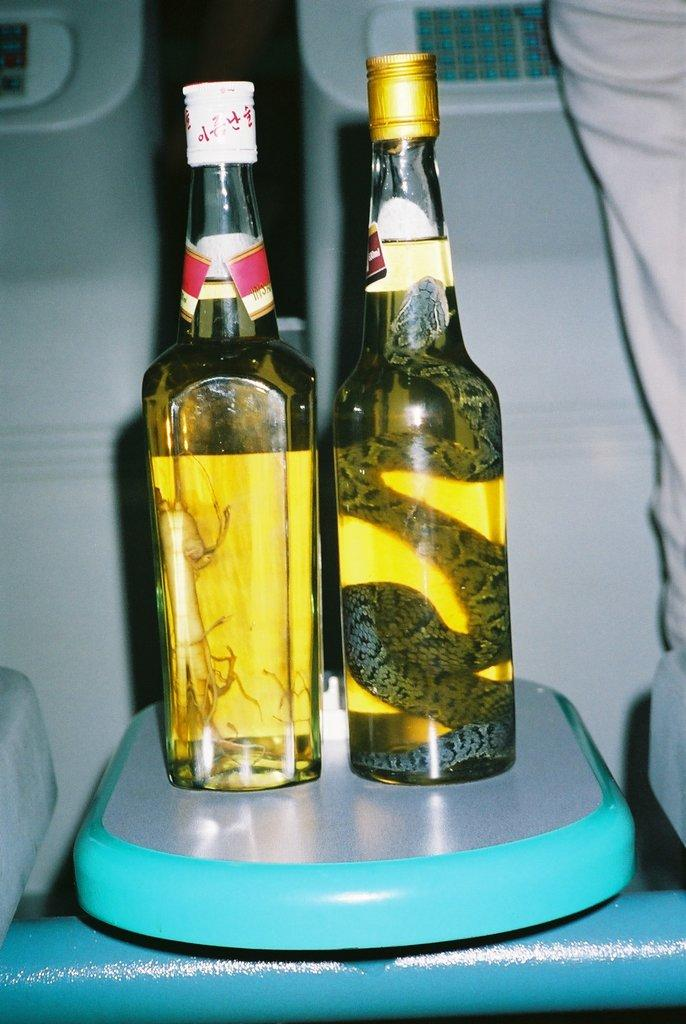How many bottles are visible in the image? There are two bottles in the image. What is inside the first bottle? The first bottle contains a snake. What is inside the second bottle? The second bottle contains an unspecified animal. What is the tendency of the suit in the image? There is no suit present in the image; it only features two bottles with different animals inside. 